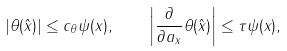<formula> <loc_0><loc_0><loc_500><loc_500>| \theta ( \hat { x } ) | \leq c _ { \theta } \psi ( x ) , \quad \left | \frac { \partial } { \partial a _ { x } } \theta ( \hat { x } ) \right | \leq \tau \psi ( x ) ,</formula> 